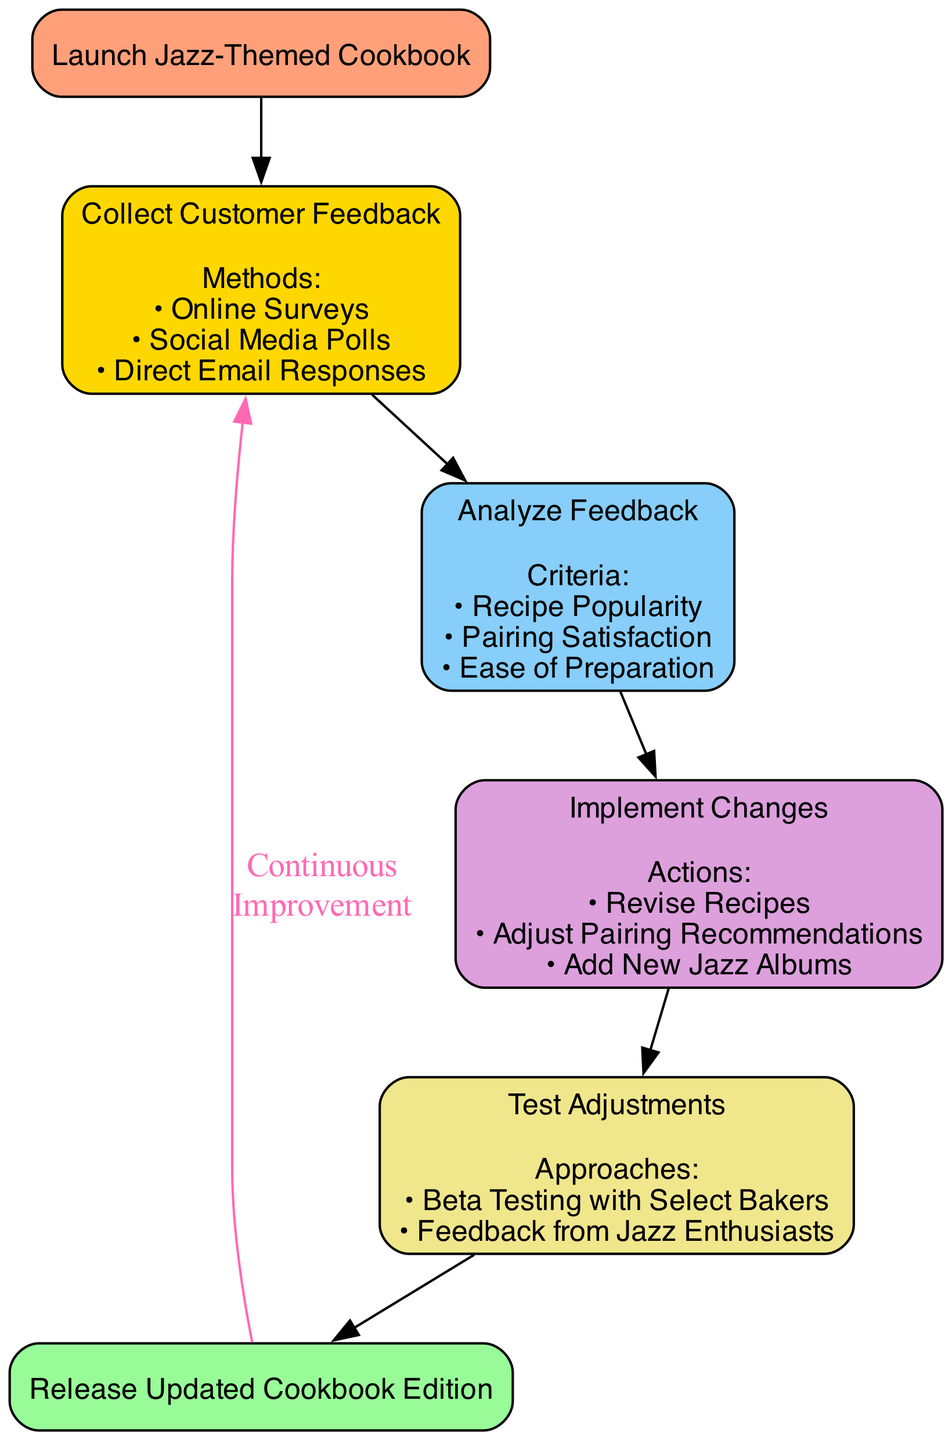What is the first step in the customer feedback loop? The first step in the loop is labeled as "Step1" and is described as "Collect Customer Feedback." This information can be found directly in the diagram’s flow starting from the "Start" node.
Answer: Collect Customer Feedback How many methods are used to collect customer feedback? In "Step1," there are three specified methods listed below the step name: "Online Surveys," "Social Media Polls," and "Direct Email Responses." Counting these methods gives us the total.
Answer: 3 What criteria are analyzed in Step2? The criteria analyzed in "Step2" are listed right after the step name: "Recipe Popularity," "Pairing Satisfaction," and "Ease of Preparation." This can be directly read from the diagram under "Step2."
Answer: Recipe Popularity, Pairing Satisfaction, Ease of Preparation Which step follows after implementing changes? The next step that follows "Step3" (Implement Changes) is "Step4," which is indicated by the arrow leading from "Step3" to "Step4" in the flow chart.
Answer: Step4 What color is used for the Start node? The "Start" node is filled with a light salmon color, specifically labeled as '#FFA07A.' This color is explicitly mentioned in the attributes set for the "Start" node in the diagram.
Answer: #FFA07A Which actions are involved in Step3? In "Step3," the actions are displayed directly under the step name: "Revise Recipes," "Adjust Pairing Recommendations," and "Add New Jazz Albums." These actions are listed and can be read straight from the node for "Step3."
Answer: Revise Recipes, Adjust Pairing Recommendations, Add New Jazz Albums How does the process conclude in the flow chart? The conclusion of the process is represented by the "End" node, which is labeled as "Release Updated Cookbook Edition." This is the final outcome in the flow as indicated by the arrow leading into this node.
Answer: Release Updated Cookbook Edition Which group provides feedback in Step4? Feedback in "Step4" is collected from two specific groups: "Beta Testing with Select Bakers" and "Feedback from Jazz Enthusiasts," both of which are mentioned under this step. This information can be derived directly from the step's details in the diagram.
Answer: Beta Testing with Select Bakers, Feedback from Jazz Enthusiasts What is the continuous improvement cycle indicated in the diagram? The diagram indicates a continuous improvement cycle by showing an arrow leading from the "End" node back to "Step1" with the label "Continuous Improvement." This shows that the feedback loop is iterative.
Answer: Continuous Improvement 